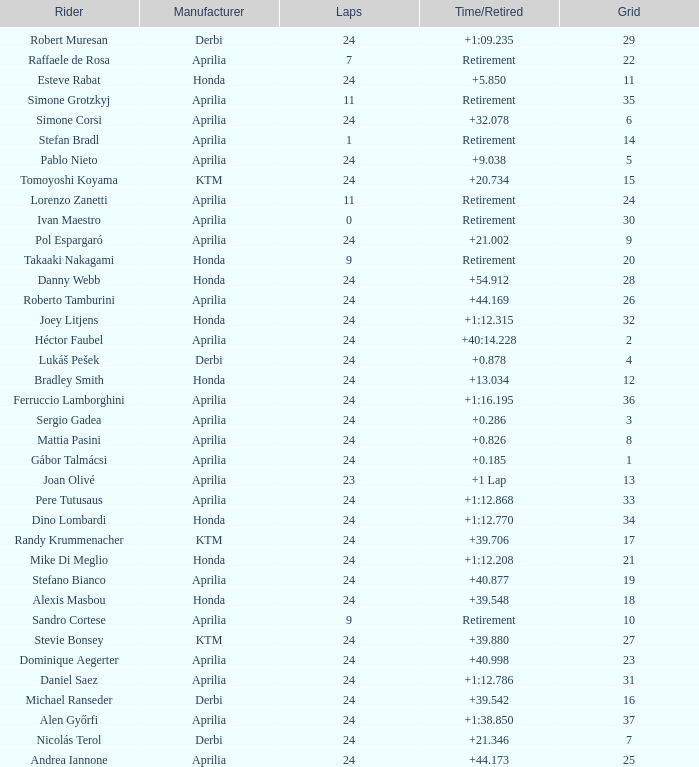What is the time with 10 grids? Retirement. 